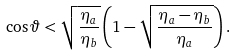Convert formula to latex. <formula><loc_0><loc_0><loc_500><loc_500>\cos \vartheta < \sqrt { \frac { \eta _ { a } } { \eta _ { b } } } \left ( 1 - \sqrt { \frac { \eta _ { a } - \eta _ { b } } { \eta _ { a } } } \right ) .</formula> 